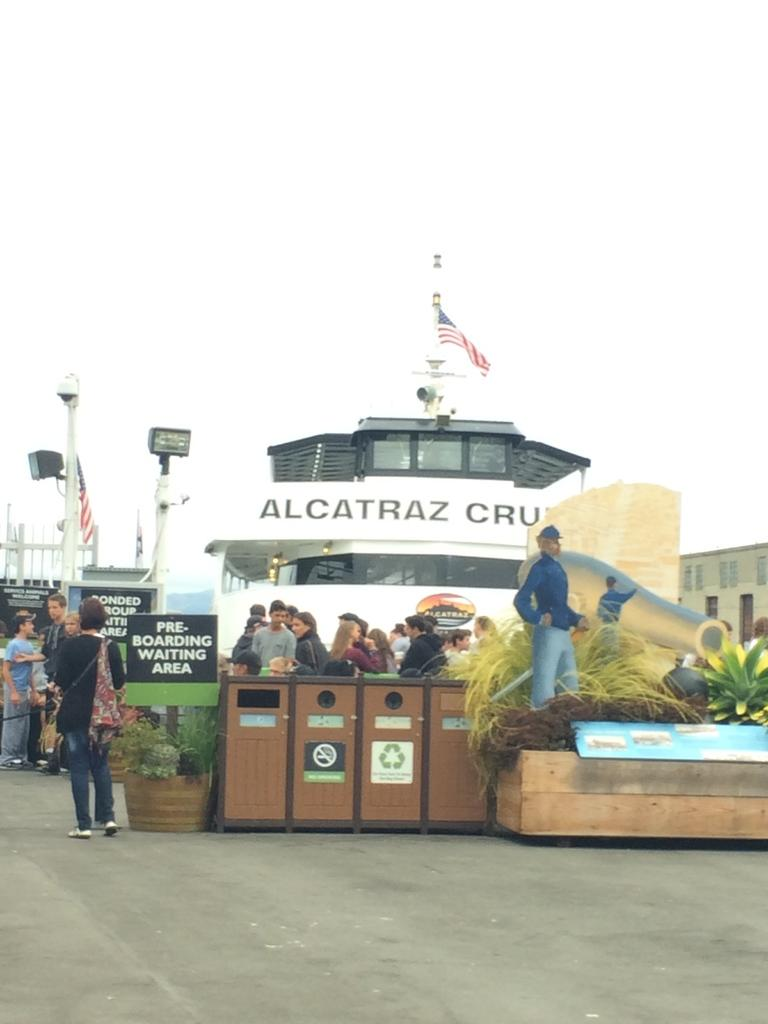What are the people in the image doing? The people in the image are standing on the road. What other objects or figures can be seen in the image? There are mannequins, information boards, plants, electric lights, a flag, and buildings present in the image. What can be seen in the sky in the image? The sky is visible in the image. Are there any cats participating in a protest in the image? There are no cats or protest depicted in the image. What type of car can be seen driving through the scene in the image? There is no car present in the image; it only features people, mannequins, information boards, plants, electric lights, a flag, buildings, and the sky. 